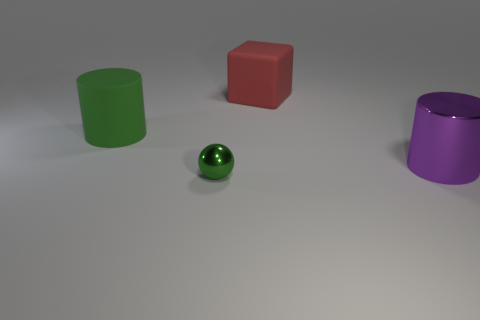There is a large object that is the same color as the small sphere; what is it made of?
Keep it short and to the point. Rubber. Is there a tiny sphere that has the same color as the rubber cylinder?
Keep it short and to the point. Yes. What number of large green rubber things are behind the cylinder that is in front of the green rubber thing?
Offer a terse response. 1. Are there more green matte things than tiny yellow blocks?
Ensure brevity in your answer.  Yes. Is the tiny green object made of the same material as the big purple object?
Provide a succinct answer. Yes. Is the number of things in front of the ball the same as the number of yellow metallic things?
Offer a terse response. Yes. How many purple cylinders have the same material as the big green cylinder?
Provide a short and direct response. 0. Are there fewer red matte blocks than cyan metallic cubes?
Your response must be concise. No. There is a cylinder that is right of the tiny green metallic sphere; does it have the same color as the tiny thing?
Make the answer very short. No. What number of large purple shiny objects are behind the green thing behind the metal object in front of the big metal thing?
Make the answer very short. 0. 